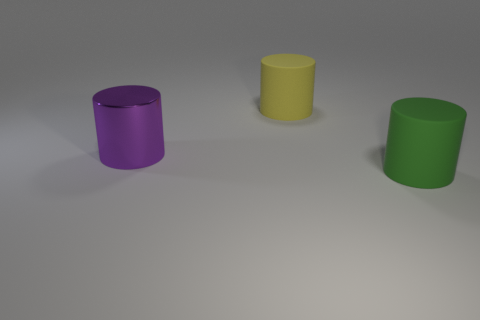Subtract all green rubber cylinders. How many cylinders are left? 2 Subtract all yellow cylinders. How many cylinders are left? 2 Add 2 big brown cubes. How many objects exist? 5 Subtract 0 red spheres. How many objects are left? 3 Subtract all green cylinders. Subtract all green cubes. How many cylinders are left? 2 Subtract all purple spheres. How many purple cylinders are left? 1 Subtract all big cyan shiny cubes. Subtract all yellow matte things. How many objects are left? 2 Add 3 purple metallic cylinders. How many purple metallic cylinders are left? 4 Add 2 green things. How many green things exist? 3 